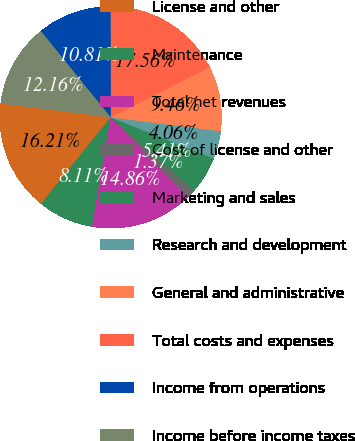<chart> <loc_0><loc_0><loc_500><loc_500><pie_chart><fcel>License and other<fcel>Maintenance<fcel>Total net revenues<fcel>Cost of license and other<fcel>Marketing and sales<fcel>Research and development<fcel>General and administrative<fcel>Total costs and expenses<fcel>Income from operations<fcel>Income before income taxes<nl><fcel>16.21%<fcel>8.11%<fcel>14.86%<fcel>1.37%<fcel>5.41%<fcel>4.06%<fcel>9.46%<fcel>17.56%<fcel>10.81%<fcel>12.16%<nl></chart> 